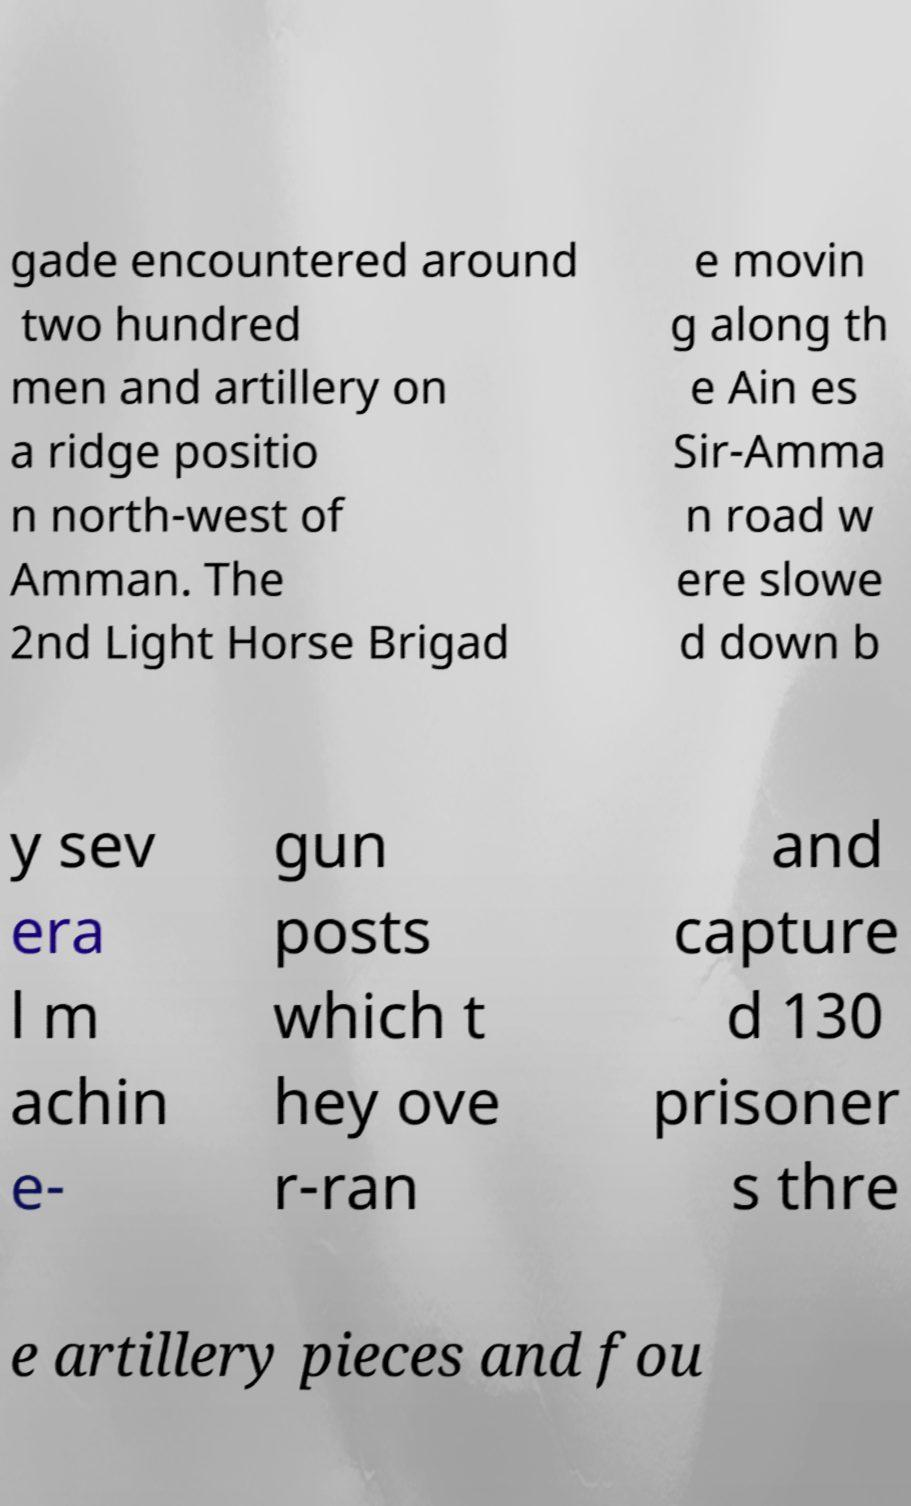I need the written content from this picture converted into text. Can you do that? gade encountered around two hundred men and artillery on a ridge positio n north-west of Amman. The 2nd Light Horse Brigad e movin g along th e Ain es Sir-Amma n road w ere slowe d down b y sev era l m achin e- gun posts which t hey ove r-ran and capture d 130 prisoner s thre e artillery pieces and fou 